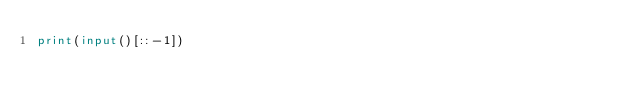<code> <loc_0><loc_0><loc_500><loc_500><_Python_>print(input()[::-1])
</code> 